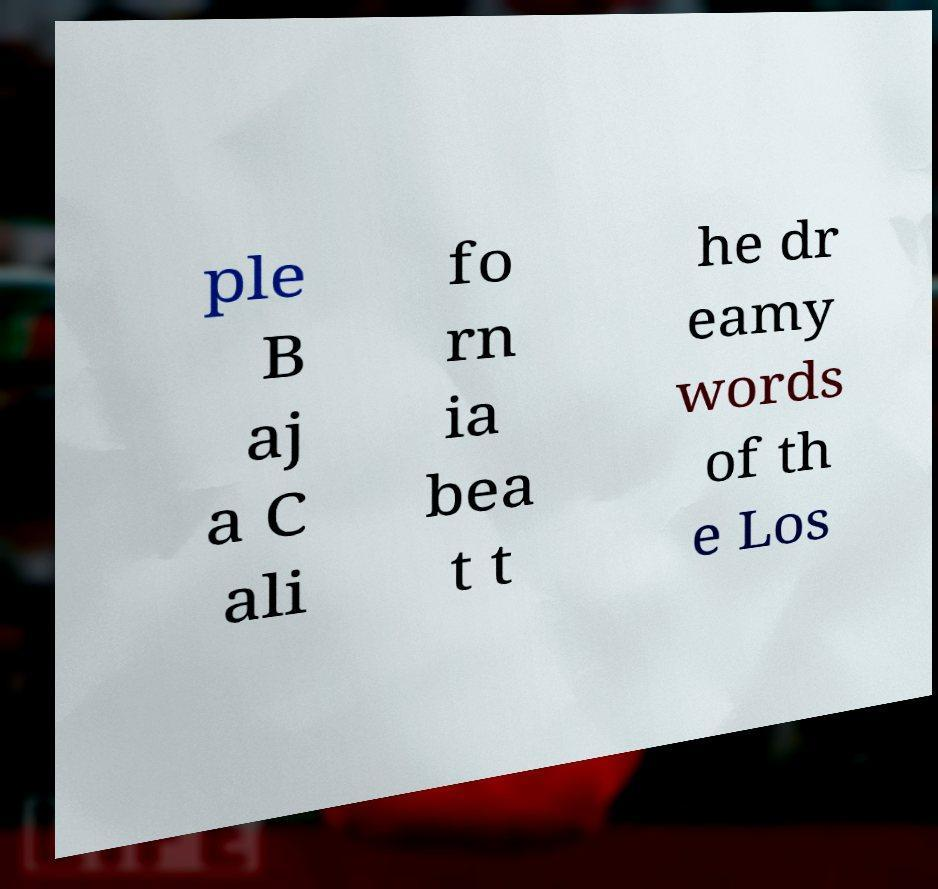I need the written content from this picture converted into text. Can you do that? ple B aj a C ali fo rn ia bea t t he dr eamy words of th e Los 